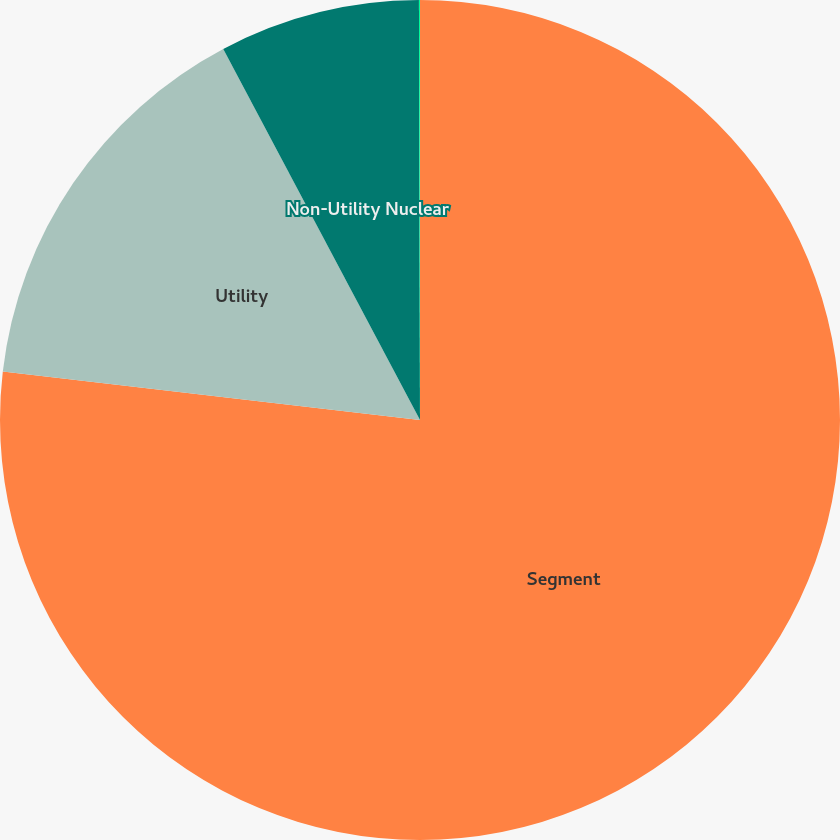Convert chart to OTSL. <chart><loc_0><loc_0><loc_500><loc_500><pie_chart><fcel>Segment<fcel>Utility<fcel>Non-Utility Nuclear<fcel>Parent Company & Other<nl><fcel>76.84%<fcel>15.4%<fcel>7.72%<fcel>0.04%<nl></chart> 